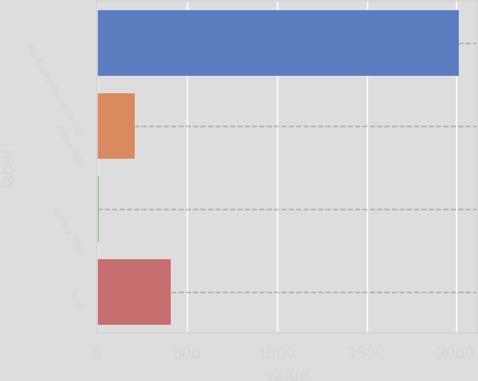<chart> <loc_0><loc_0><loc_500><loc_500><bar_chart><fcel>Year Ended December 31<fcel>Andes SBU<fcel>Eurasia SBU<fcel>Total<nl><fcel>2016<fcel>213.3<fcel>13<fcel>413.6<nl></chart> 